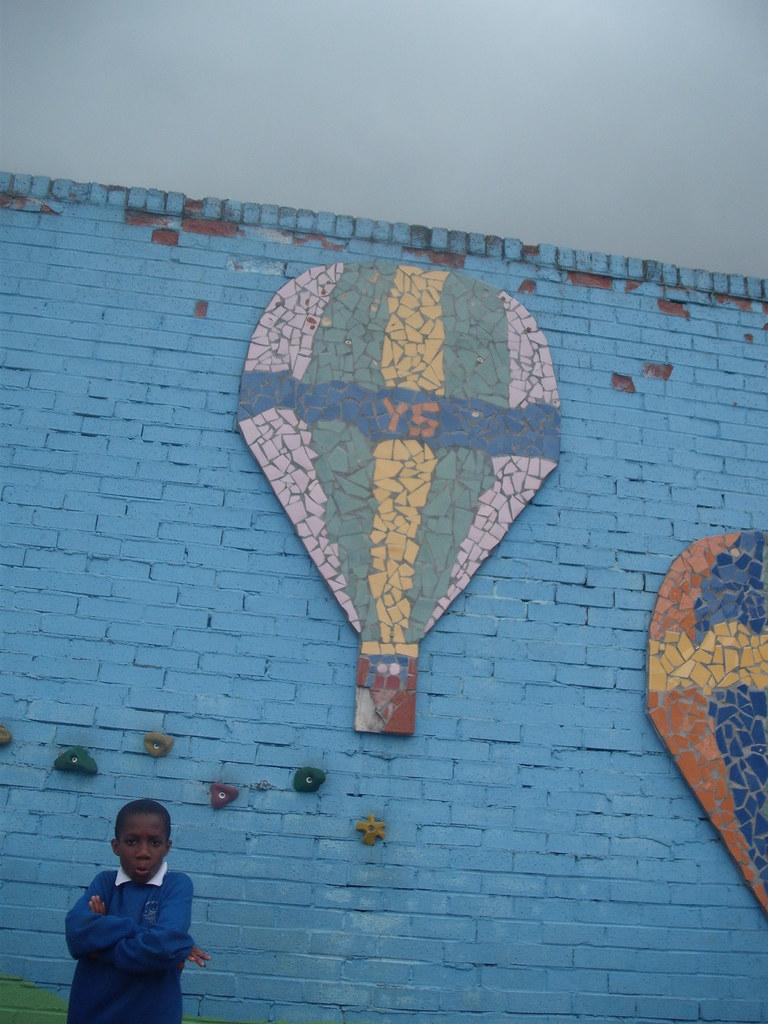What is the main subject of the image? There is a person standing in the image. Can you describe the person's clothing? The person is wearing a blue shirt. What color is the background wall in the image? The background wall is blue. How would you describe the sky in the image? The sky appears to be white in color. What type of bird can be seen sitting on the pump in the image? There is no bird or pump present in the image; it features a person standing in front of a blue wall with a white sky. 